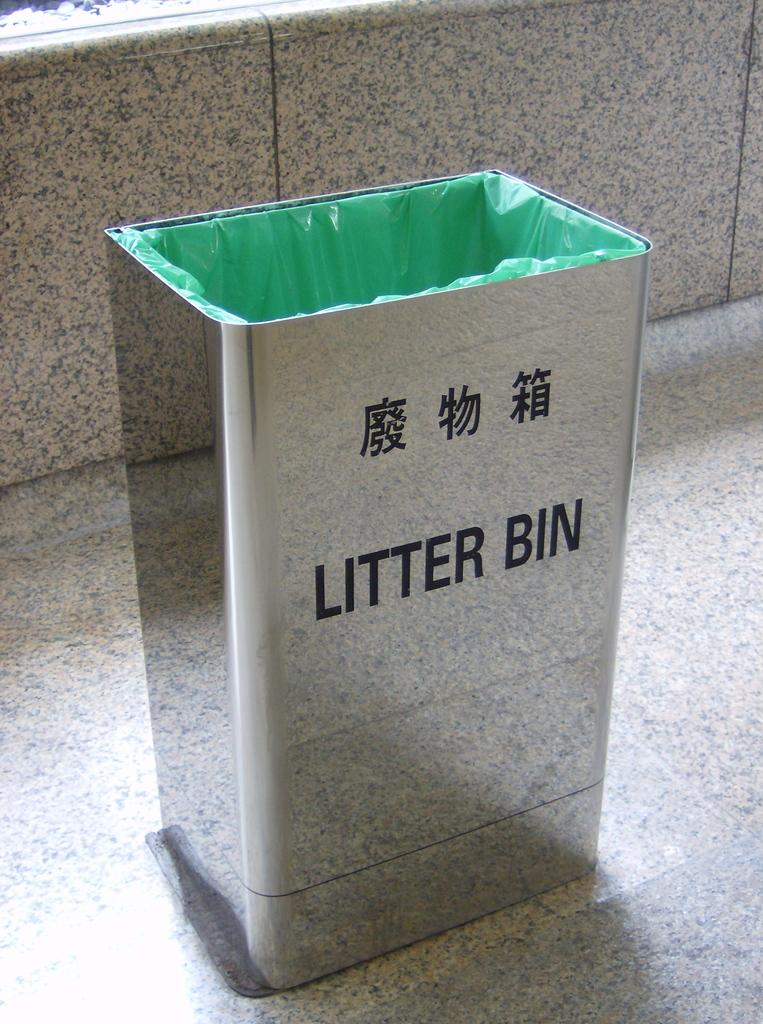<image>
Provide a brief description of the given image. A mirrored finish litter bin that is bilingual. 